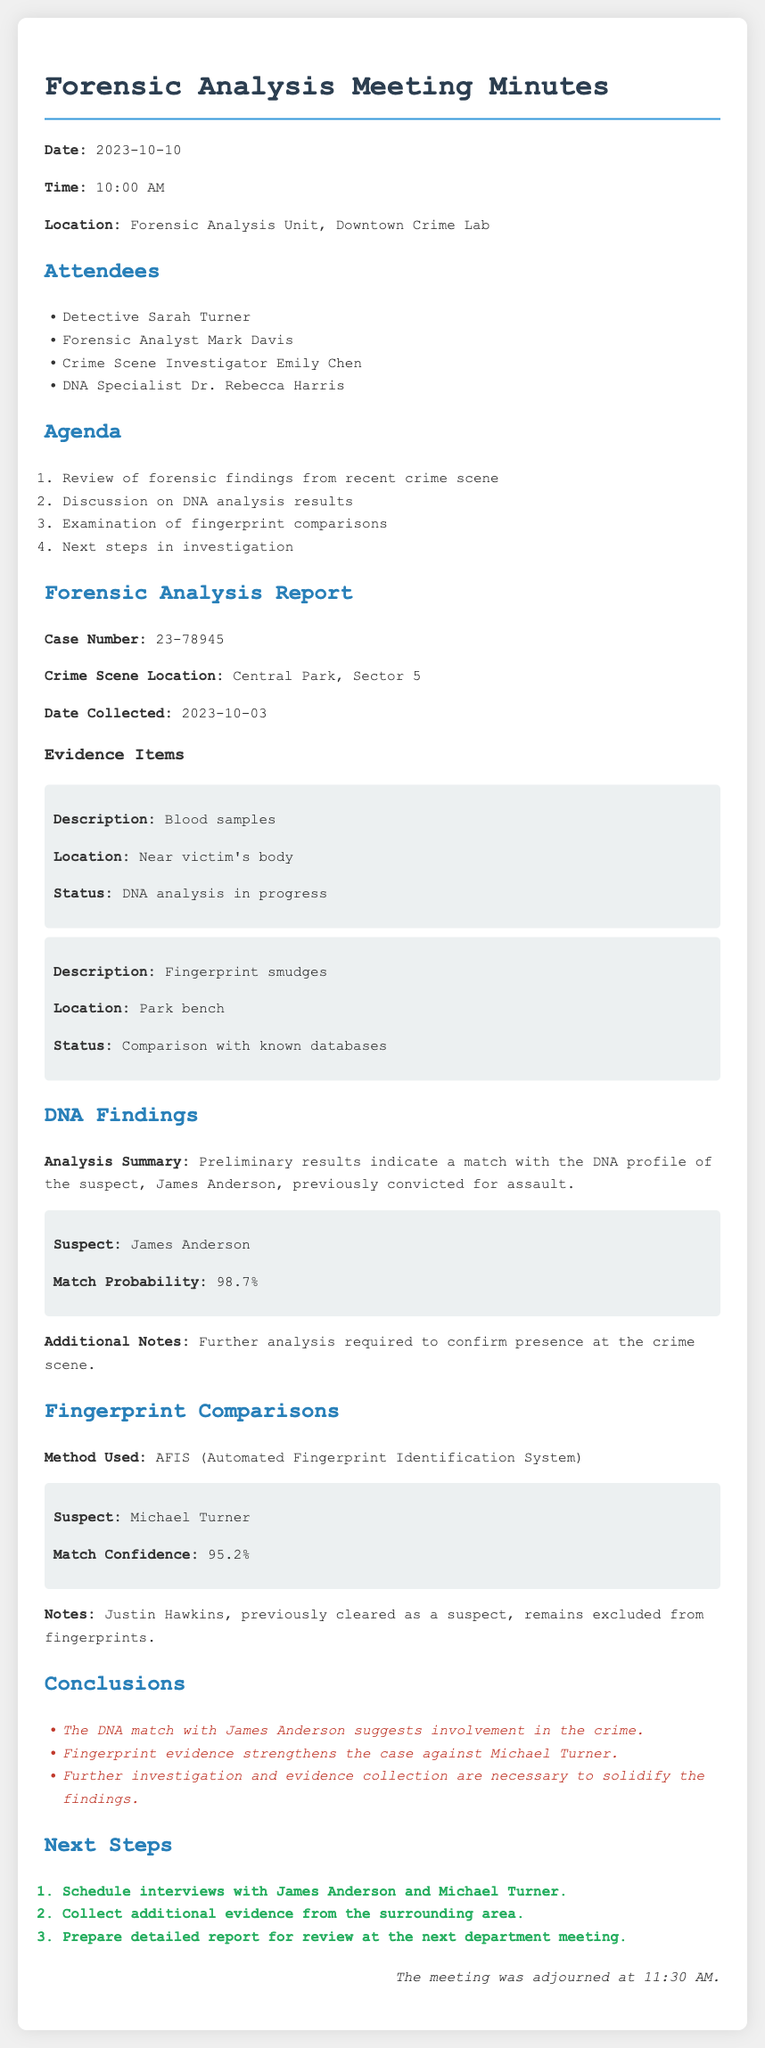What is the date of the meeting? The date is explicitly mentioned in the document header under "Date."
Answer: 2023-10-10 Who is the DNA specialist present? The document lists attendees, and the DNA specialist is mentioned there.
Answer: Dr. Rebecca Harris What is the crime scene location? The crime scene location is provided under the forensic analysis report section.
Answer: Central Park, Sector 5 What is the match probability for James Anderson's DNA? The match probability for DNA is specified in the DNA findings section.
Answer: 98.7% What method was used for fingerprint comparisons? The method used is outlined in the fingerprint comparisons section.
Answer: AFIS Which suspect was previously cleared from fingerprints? The notes in the fingerprint comparisons section mention the excluded suspect.
Answer: Justin Hawkins What is the confidence level for fingerprints matched to Michael Turner? The fingerprint comparison includes the confidence level found in the matching section.
Answer: 95.2% What is the status of the blood samples evidence? The status of the blood samples is listed under evidence items in the forensic analysis report.
Answer: DNA analysis in progress What is one of the conclusions drawn from the forensic analysis? The conclusions summarize insights found at the end of the report.
Answer: The DNA match with James Anderson suggests involvement in the crime What is one of the next steps in the investigation? The next steps are outlined in their respective section towards the end of the document.
Answer: Schedule interviews with James Anderson and Michael Turner 